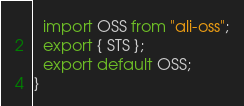Convert code to text. <code><loc_0><loc_0><loc_500><loc_500><_TypeScript_>  import OSS from "ali-oss";
  export { STS };
  export default OSS;
}
</code> 